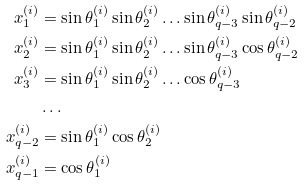Convert formula to latex. <formula><loc_0><loc_0><loc_500><loc_500>x _ { 1 } ^ { ( i ) } & = \sin \theta _ { 1 } ^ { ( i ) } \sin \theta _ { 2 } ^ { ( i ) } \dots \sin \theta _ { q - 3 } ^ { ( i ) } \sin \theta _ { q - 2 } ^ { ( i ) } \\ x _ { 2 } ^ { ( i ) } & = \sin \theta _ { 1 } ^ { ( i ) } \sin \theta _ { 2 } ^ { ( i ) } \dots \sin \theta _ { q - 3 } ^ { ( i ) } \cos \theta _ { q - 2 } ^ { ( i ) } \\ x _ { 3 } ^ { ( i ) } & = \sin \theta _ { 1 } ^ { ( i ) } \sin \theta _ { 2 } ^ { ( i ) } \dots \cos \theta _ { q - 3 } ^ { ( i ) } \\ & \dots \\ x _ { q - 2 } ^ { ( i ) } & = \sin \theta _ { 1 } ^ { ( i ) } \cos \theta _ { 2 } ^ { ( i ) } \\ x _ { q - 1 } ^ { ( i ) } & = \cos \theta _ { 1 } ^ { ( i ) }</formula> 